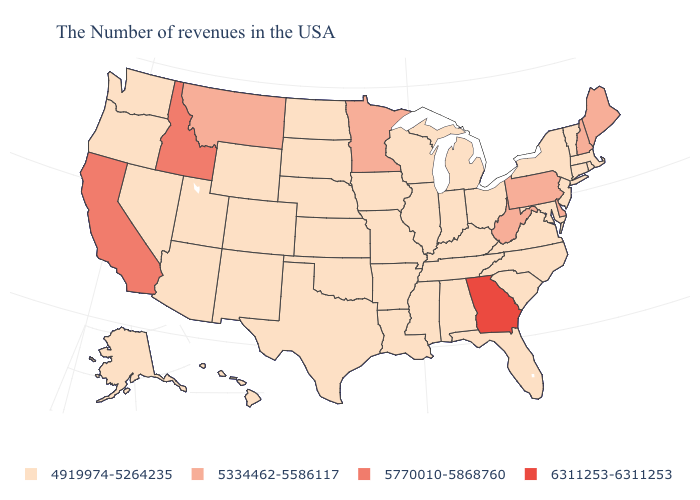Name the states that have a value in the range 5334462-5586117?
Keep it brief. Maine, New Hampshire, Delaware, Pennsylvania, West Virginia, Minnesota, Montana. What is the value of Illinois?
Keep it brief. 4919974-5264235. Does West Virginia have a higher value than Pennsylvania?
Short answer required. No. Name the states that have a value in the range 4919974-5264235?
Concise answer only. Massachusetts, Rhode Island, Vermont, Connecticut, New York, New Jersey, Maryland, Virginia, North Carolina, South Carolina, Ohio, Florida, Michigan, Kentucky, Indiana, Alabama, Tennessee, Wisconsin, Illinois, Mississippi, Louisiana, Missouri, Arkansas, Iowa, Kansas, Nebraska, Oklahoma, Texas, South Dakota, North Dakota, Wyoming, Colorado, New Mexico, Utah, Arizona, Nevada, Washington, Oregon, Alaska, Hawaii. What is the lowest value in states that border Iowa?
Concise answer only. 4919974-5264235. Name the states that have a value in the range 4919974-5264235?
Short answer required. Massachusetts, Rhode Island, Vermont, Connecticut, New York, New Jersey, Maryland, Virginia, North Carolina, South Carolina, Ohio, Florida, Michigan, Kentucky, Indiana, Alabama, Tennessee, Wisconsin, Illinois, Mississippi, Louisiana, Missouri, Arkansas, Iowa, Kansas, Nebraska, Oklahoma, Texas, South Dakota, North Dakota, Wyoming, Colorado, New Mexico, Utah, Arizona, Nevada, Washington, Oregon, Alaska, Hawaii. What is the value of Michigan?
Concise answer only. 4919974-5264235. Name the states that have a value in the range 5770010-5868760?
Concise answer only. Idaho, California. Does the map have missing data?
Write a very short answer. No. What is the value of New Jersey?
Be succinct. 4919974-5264235. Name the states that have a value in the range 5770010-5868760?
Answer briefly. Idaho, California. Name the states that have a value in the range 5334462-5586117?
Quick response, please. Maine, New Hampshire, Delaware, Pennsylvania, West Virginia, Minnesota, Montana. Does Idaho have a lower value than Iowa?
Short answer required. No. What is the value of Ohio?
Concise answer only. 4919974-5264235. Which states hav the highest value in the Northeast?
Be succinct. Maine, New Hampshire, Pennsylvania. 